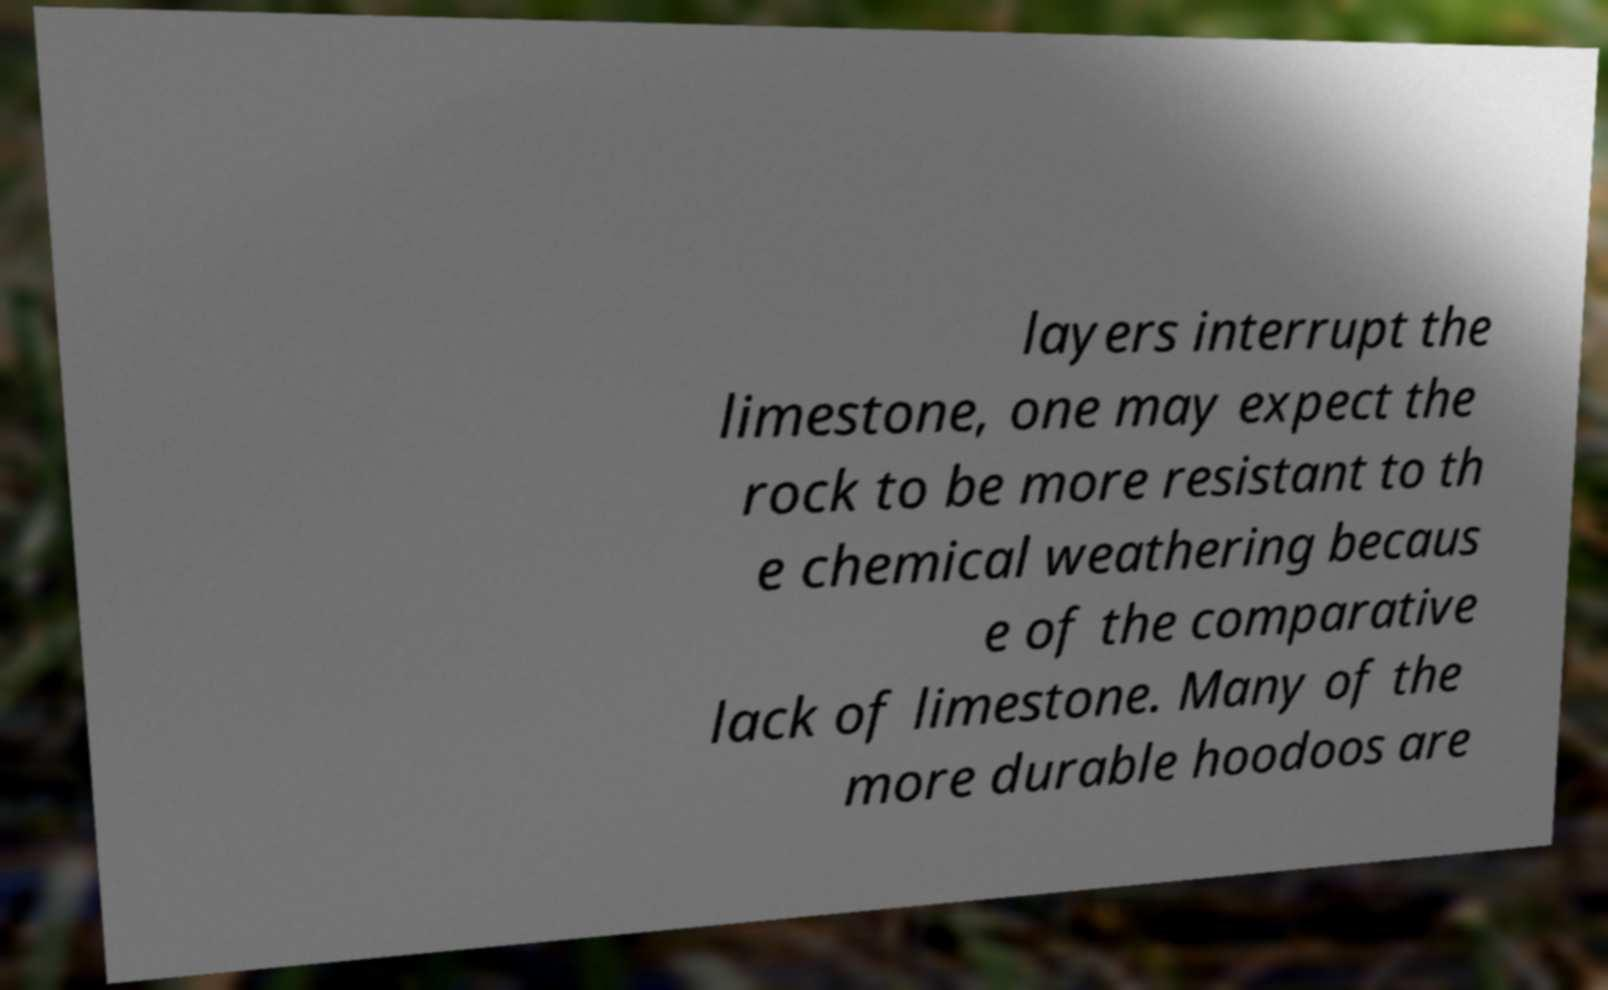Could you extract and type out the text from this image? layers interrupt the limestone, one may expect the rock to be more resistant to th e chemical weathering becaus e of the comparative lack of limestone. Many of the more durable hoodoos are 